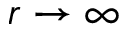Convert formula to latex. <formula><loc_0><loc_0><loc_500><loc_500>r \rightarrow \infty</formula> 